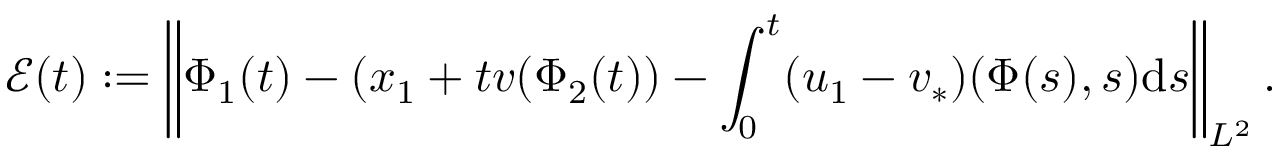<formula> <loc_0><loc_0><loc_500><loc_500>\mathcal { E } ( t ) \colon = \left \| { \Phi } _ { 1 } ( t ) - ( x _ { 1 } + t v ( \Phi _ { 2 } ( t ) ) - \int _ { 0 } ^ { t } ( u _ { 1 } - v _ { * } ) ( \Phi ( s ) , s ) d s \right \| _ { L ^ { 2 } } .</formula> 